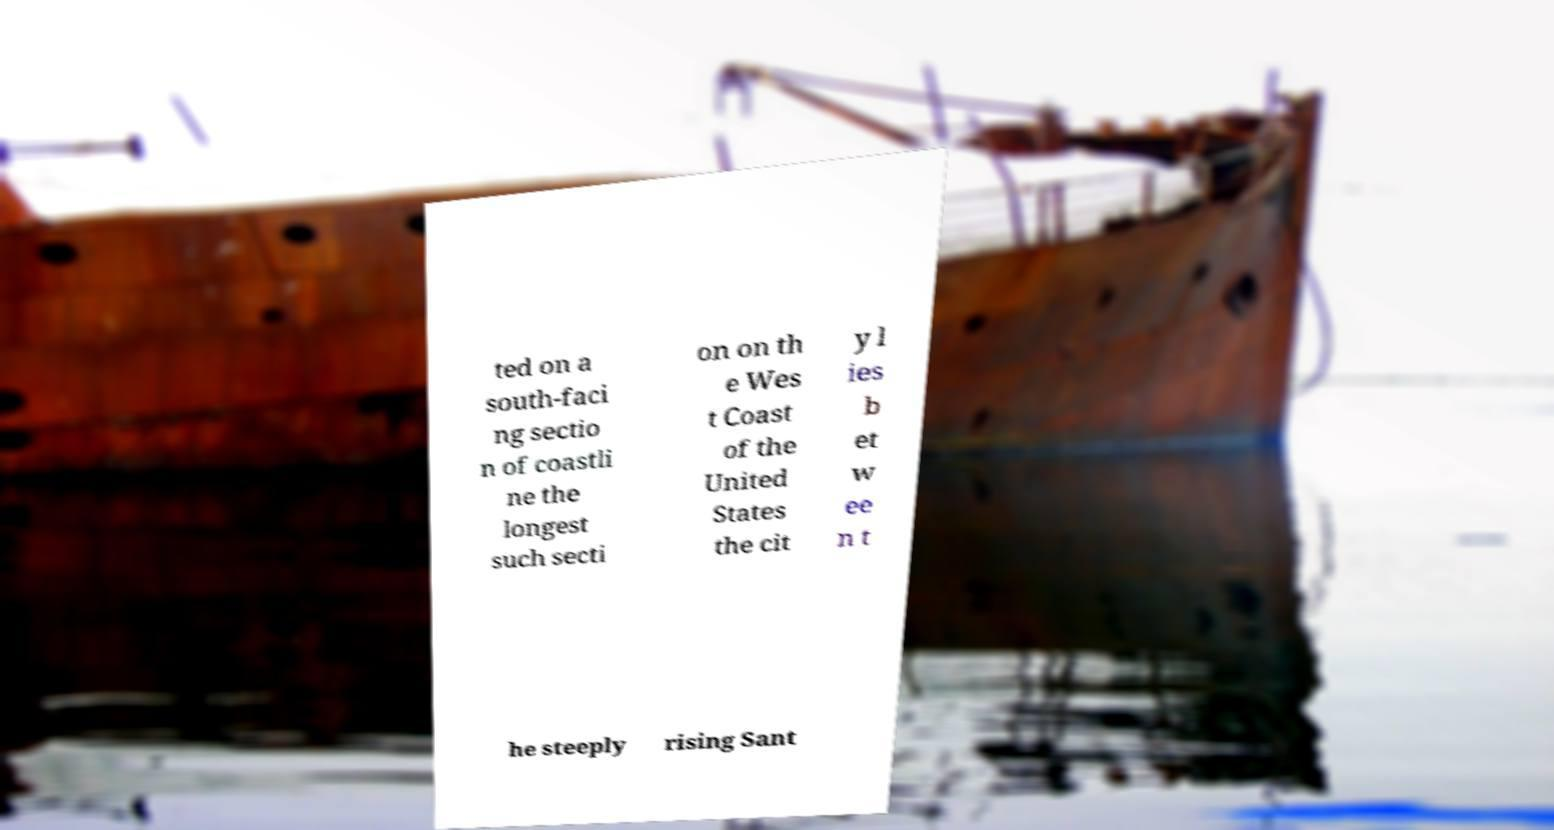Can you read and provide the text displayed in the image?This photo seems to have some interesting text. Can you extract and type it out for me? ted on a south-faci ng sectio n of coastli ne the longest such secti on on th e Wes t Coast of the United States the cit y l ies b et w ee n t he steeply rising Sant 